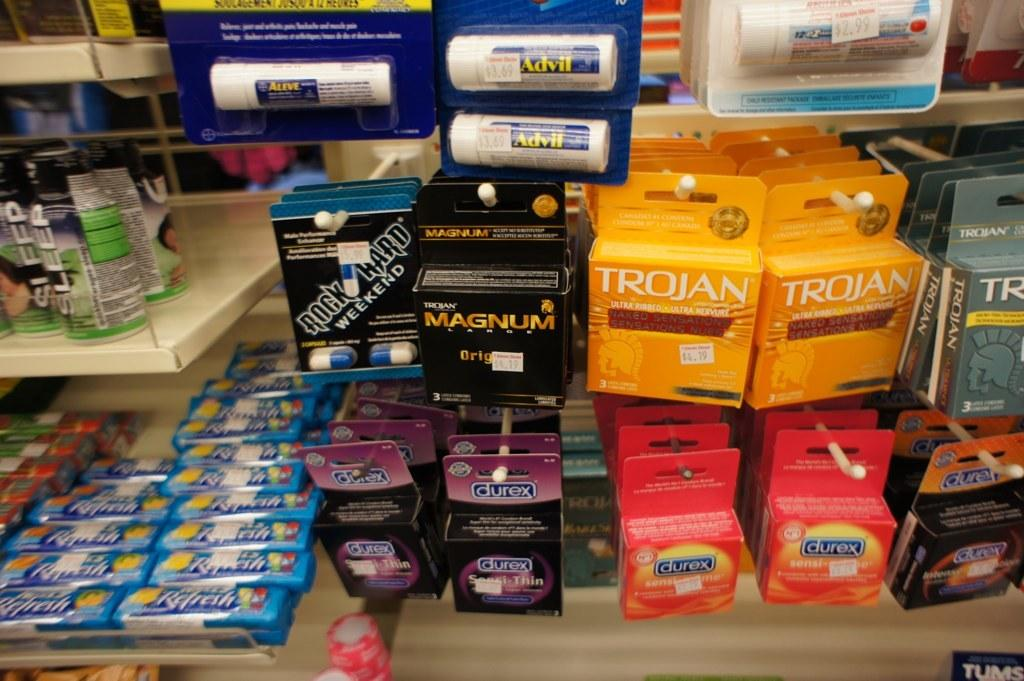<image>
Describe the image concisely. A display of various things with Trojan condoms in orange boxes 